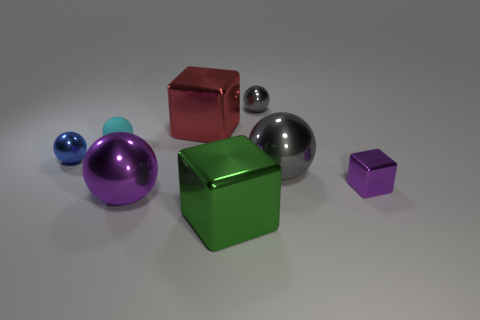What material is the large purple object that is the same shape as the big gray thing?
Keep it short and to the point. Metal. Does the small shiny thing that is to the left of the small gray shiny ball have the same shape as the gray thing behind the cyan matte ball?
Provide a succinct answer. Yes. Are there fewer large objects on the left side of the tiny gray metal ball than things that are right of the tiny cyan rubber object?
Your response must be concise. Yes. How many other things are the same shape as the big gray thing?
Your response must be concise. 4. What is the shape of the other gray object that is the same material as the tiny gray object?
Keep it short and to the point. Sphere. There is a tiny thing that is in front of the small cyan object and to the left of the big purple ball; what color is it?
Provide a succinct answer. Blue. Are the gray object that is in front of the blue object and the small cyan object made of the same material?
Keep it short and to the point. No. Is the number of tiny purple shiny things that are behind the large green metallic object less than the number of small shiny spheres?
Keep it short and to the point. Yes. Is there a gray ball that has the same material as the purple block?
Make the answer very short. Yes. Is the size of the cyan rubber ball the same as the purple object that is on the left side of the big green metallic thing?
Offer a terse response. No. 